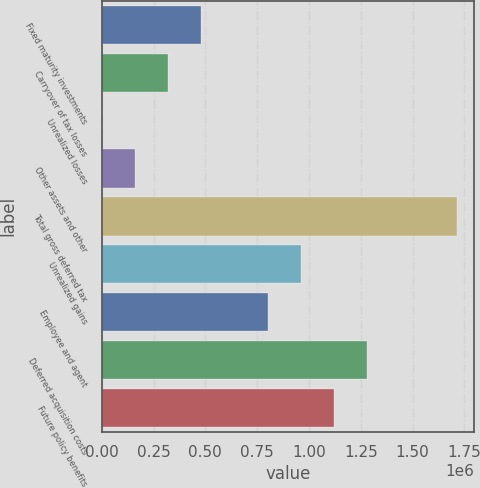Convert chart to OTSL. <chart><loc_0><loc_0><loc_500><loc_500><bar_chart><fcel>Fixed maturity investments<fcel>Carryover of tax losses<fcel>Unrealized losses<fcel>Other assets and other<fcel>Total gross deferred tax<fcel>Unrealized gains<fcel>Employee and agent<fcel>Deferred acquisition costs<fcel>Future policy benefits<nl><fcel>480413<fcel>320276<fcel>3.29<fcel>160140<fcel>1.7129e+06<fcel>960822<fcel>800686<fcel>1.2811e+06<fcel>1.12096e+06<nl></chart> 